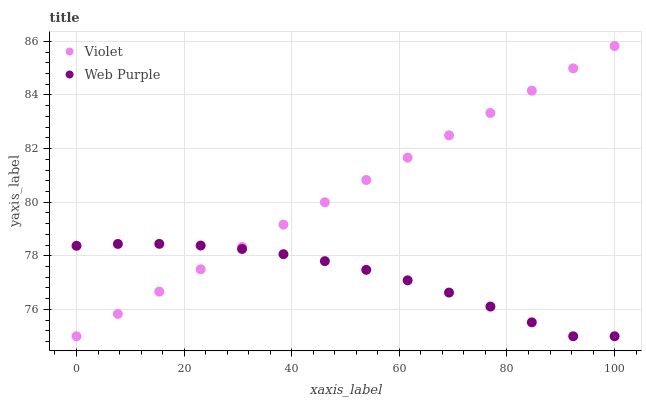Does Web Purple have the minimum area under the curve?
Answer yes or no. Yes. Does Violet have the maximum area under the curve?
Answer yes or no. Yes. Does Violet have the minimum area under the curve?
Answer yes or no. No. Is Violet the smoothest?
Answer yes or no. Yes. Is Web Purple the roughest?
Answer yes or no. Yes. Is Violet the roughest?
Answer yes or no. No. Does Web Purple have the lowest value?
Answer yes or no. Yes. Does Violet have the highest value?
Answer yes or no. Yes. Does Violet intersect Web Purple?
Answer yes or no. Yes. Is Violet less than Web Purple?
Answer yes or no. No. Is Violet greater than Web Purple?
Answer yes or no. No. 